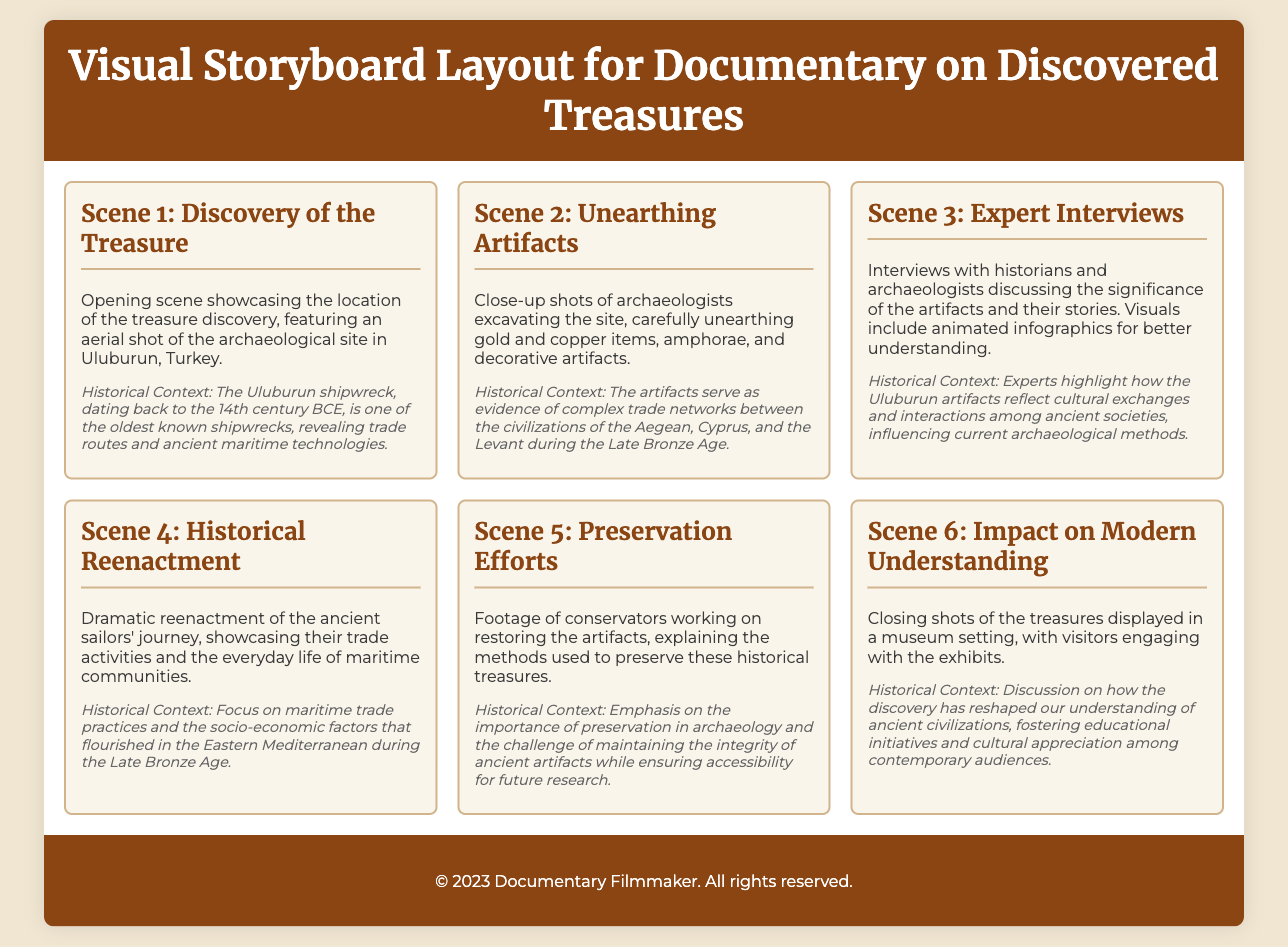What is the title of the documentary? The title is explicitly stated in the document's header section.
Answer: Visual Storyboard: Unearthed Treasures Documentary Where is the treasure discovery located? The location is mentioned in the first scene description.
Answer: Uluburun, Turkey What century does the Uluburun shipwreck date back to? The exact century is detailed in the historical context of Scene 1.
Answer: 14th century BCE What types of items are mentioned as artifacts being unearthed? The specific items are listed in the description of Scene 2.
Answer: Gold and copper items, amphorae, decorative artifacts What is emphasized in Scene 5 regarding the artifacts? The focus of Scene 5 provides insight into preservation efforts relative to the artifacts.
Answer: Preservation in archaeology How do the artifacts reflect ancient societies? The collective insights of experts in Scene 3 elucidate the artifacts' cultural significance.
Answer: Cultural exchanges and interactions What is showcased in Scene 4? The content of Scene 4 indicates the nature of its visual depiction.
Answer: Dramatic reenactment of ancient sailors' journey What do the final scene's closing shots feature? The final scene describes what is portrayed visually and contextually.
Answer: Treasures displayed in a museum setting 